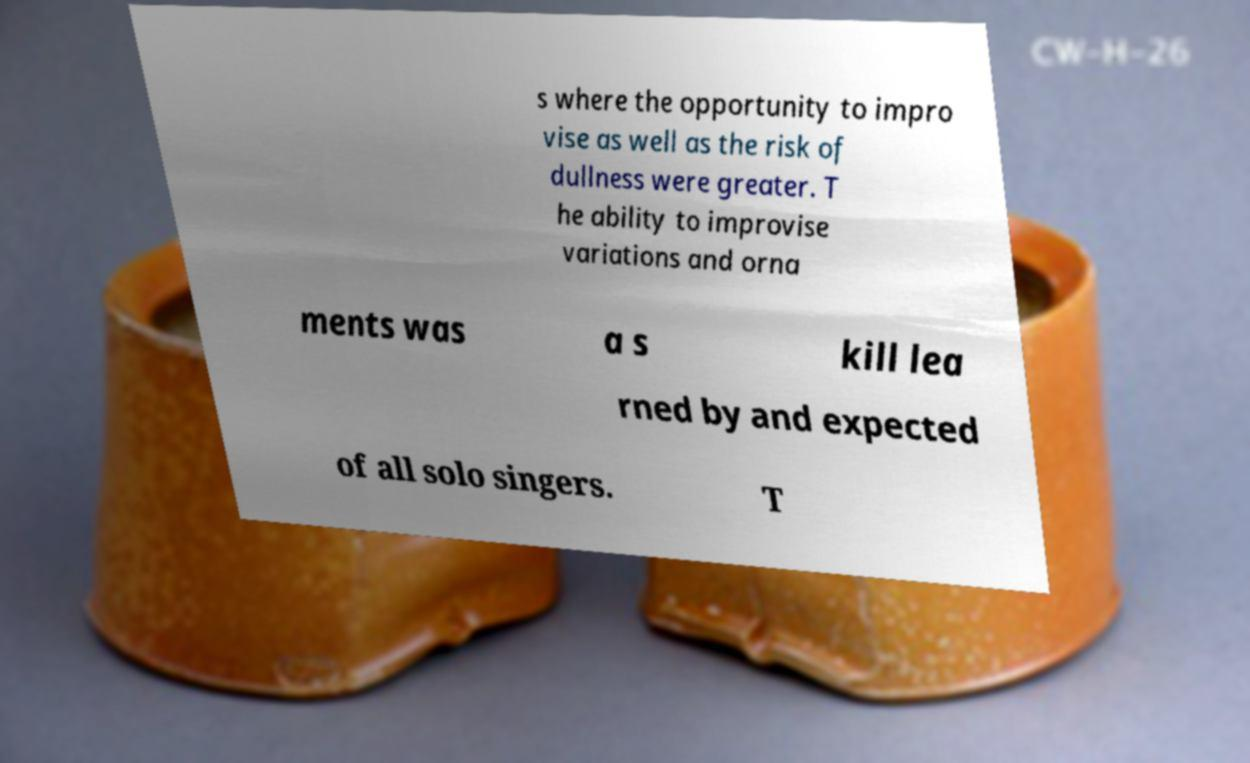I need the written content from this picture converted into text. Can you do that? s where the opportunity to impro vise as well as the risk of dullness were greater. T he ability to improvise variations and orna ments was a s kill lea rned by and expected of all solo singers. T 